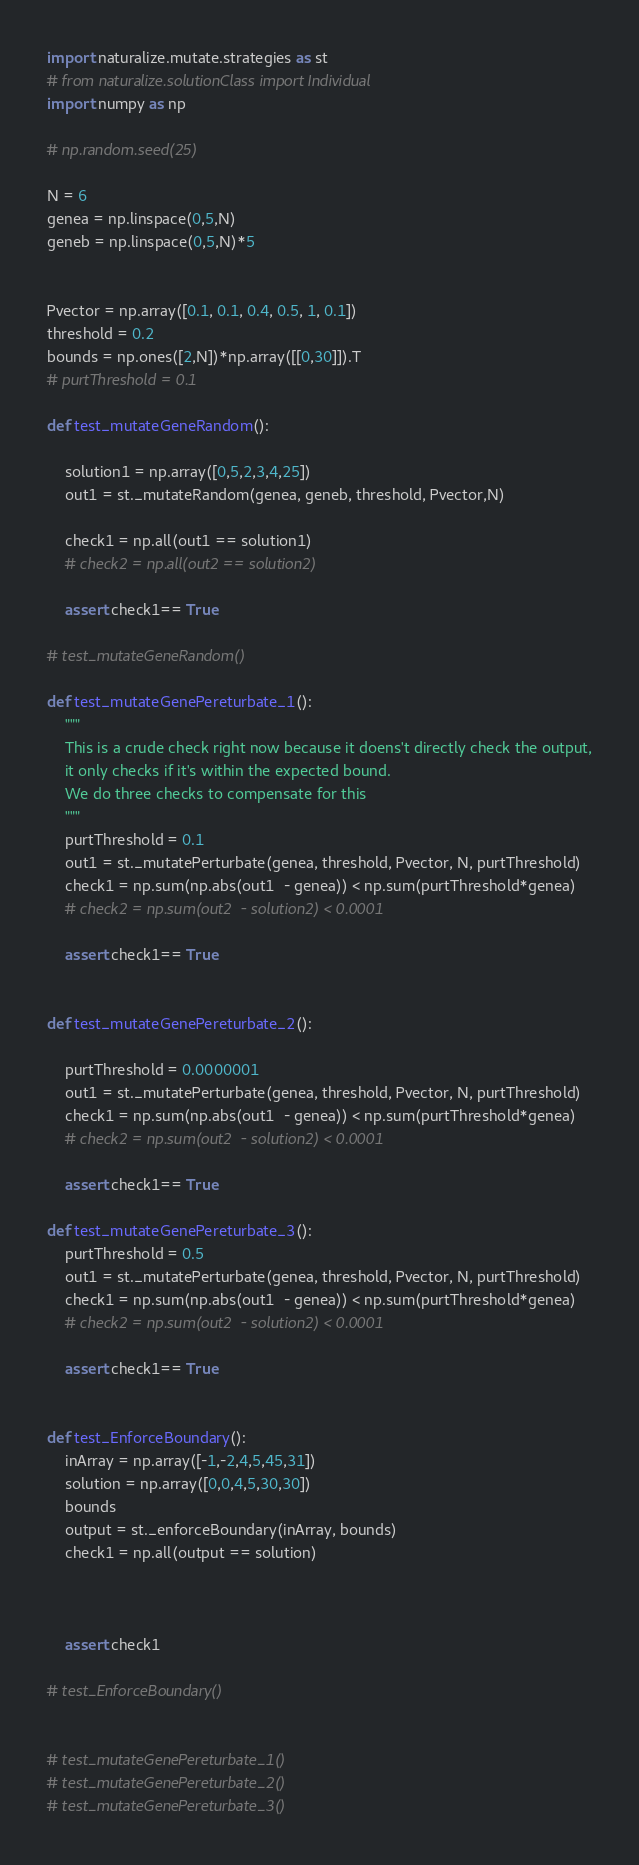<code> <loc_0><loc_0><loc_500><loc_500><_Python_>
import naturalize.mutate.strategies as st
# from naturalize.solutionClass import Individual
import numpy as np

# np.random.seed(25)

N = 6
genea = np.linspace(0,5,N)
geneb = np.linspace(0,5,N)*5


Pvector = np.array([0.1, 0.1, 0.4, 0.5, 1, 0.1])
threshold = 0.2
bounds = np.ones([2,N])*np.array([[0,30]]).T
# purtThreshold = 0.1

def test_mutateGeneRandom():

    solution1 = np.array([0,5,2,3,4,25])
    out1 = st._mutateRandom(genea, geneb, threshold, Pvector,N)
     
    check1 = np.all(out1 == solution1)
    # check2 = np.all(out2 == solution2)
    
    assert check1== True

# test_mutateGeneRandom()

def test_mutateGenePereturbate_1():
    """
    This is a crude check right now because it doens't directly check the output,
    it only checks if it's within the expected bound.
    We do three checks to compensate for this
    """
    purtThreshold = 0.1
    out1 = st._mutatePerturbate(genea, threshold, Pvector, N, purtThreshold)
    check1 = np.sum(np.abs(out1  - genea)) < np.sum(purtThreshold*genea)
    # check2 = np.sum(out2  - solution2) < 0.0001
    
    assert check1== True


def test_mutateGenePereturbate_2():

    purtThreshold = 0.0000001
    out1 = st._mutatePerturbate(genea, threshold, Pvector, N, purtThreshold)
    check1 = np.sum(np.abs(out1  - genea)) < np.sum(purtThreshold*genea)
    # check2 = np.sum(out2  - solution2) < 0.0001
    
    assert check1== True

def test_mutateGenePereturbate_3():
    purtThreshold = 0.5
    out1 = st._mutatePerturbate(genea, threshold, Pvector, N, purtThreshold)
    check1 = np.sum(np.abs(out1  - genea)) < np.sum(purtThreshold*genea)
    # check2 = np.sum(out2  - solution2) < 0.0001
    
    assert check1== True


def test_EnforceBoundary():
    inArray = np.array([-1,-2,4,5,45,31])
    solution = np.array([0,0,4,5,30,30])
    bounds
    output = st._enforceBoundary(inArray, bounds)
    check1 = np.all(output == solution)
    
    
    
    assert check1 
    
# test_EnforceBoundary()


# test_mutateGenePereturbate_1()
# test_mutateGenePereturbate_2()
# test_mutateGenePereturbate_3()</code> 